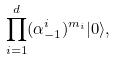<formula> <loc_0><loc_0><loc_500><loc_500>\prod _ { i = 1 } ^ { d } ( \alpha _ { - 1 } ^ { i } ) ^ { m _ { i } } | 0 \rangle ,</formula> 